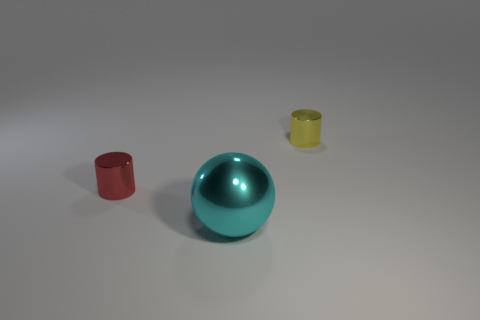There is a small red shiny cylinder; are there any small shiny things on the left side of it?
Offer a terse response. No. What size is the yellow cylinder that is the same material as the big sphere?
Provide a short and direct response. Small. Are there fewer small yellow cylinders that are in front of the yellow cylinder than cylinders that are in front of the red cylinder?
Your answer should be compact. No. There is a cyan sphere in front of the yellow metallic cylinder; how big is it?
Keep it short and to the point. Large. Are there any tiny yellow cylinders made of the same material as the large cyan sphere?
Your response must be concise. Yes. Are the big cyan ball and the red cylinder made of the same material?
Provide a short and direct response. Yes. What is the color of the shiny cylinder that is the same size as the red object?
Offer a very short reply. Yellow. What number of other objects are there of the same shape as the cyan object?
Keep it short and to the point. 0. There is a red thing; is it the same size as the metal cylinder that is to the right of the big cyan metal sphere?
Provide a succinct answer. Yes. How many things are either metallic balls or red metallic objects?
Offer a very short reply. 2. 